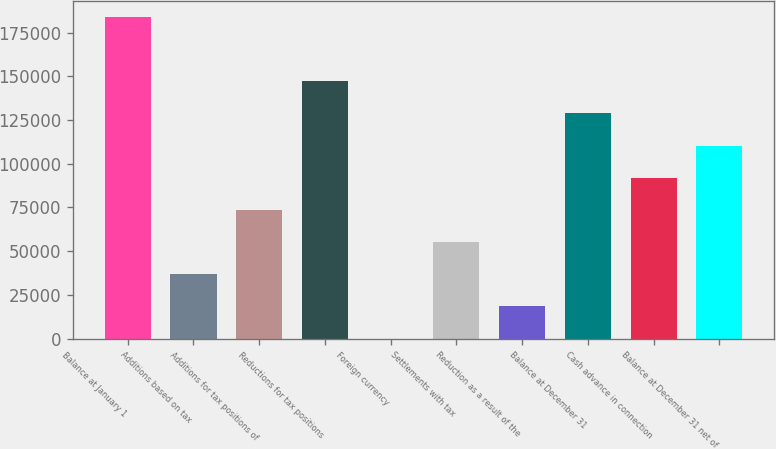Convert chart to OTSL. <chart><loc_0><loc_0><loc_500><loc_500><bar_chart><fcel>Balance at January 1<fcel>Additions based on tax<fcel>Additions for tax positions of<fcel>Reductions for tax positions<fcel>Foreign currency<fcel>Settlements with tax<fcel>Reduction as a result of the<fcel>Balance at December 31<fcel>Cash advance in connection<fcel>Balance at December 31 net of<nl><fcel>183953<fcel>36811.4<fcel>73596.8<fcel>147168<fcel>26<fcel>55204.1<fcel>18418.7<fcel>128775<fcel>91989.5<fcel>110382<nl></chart> 